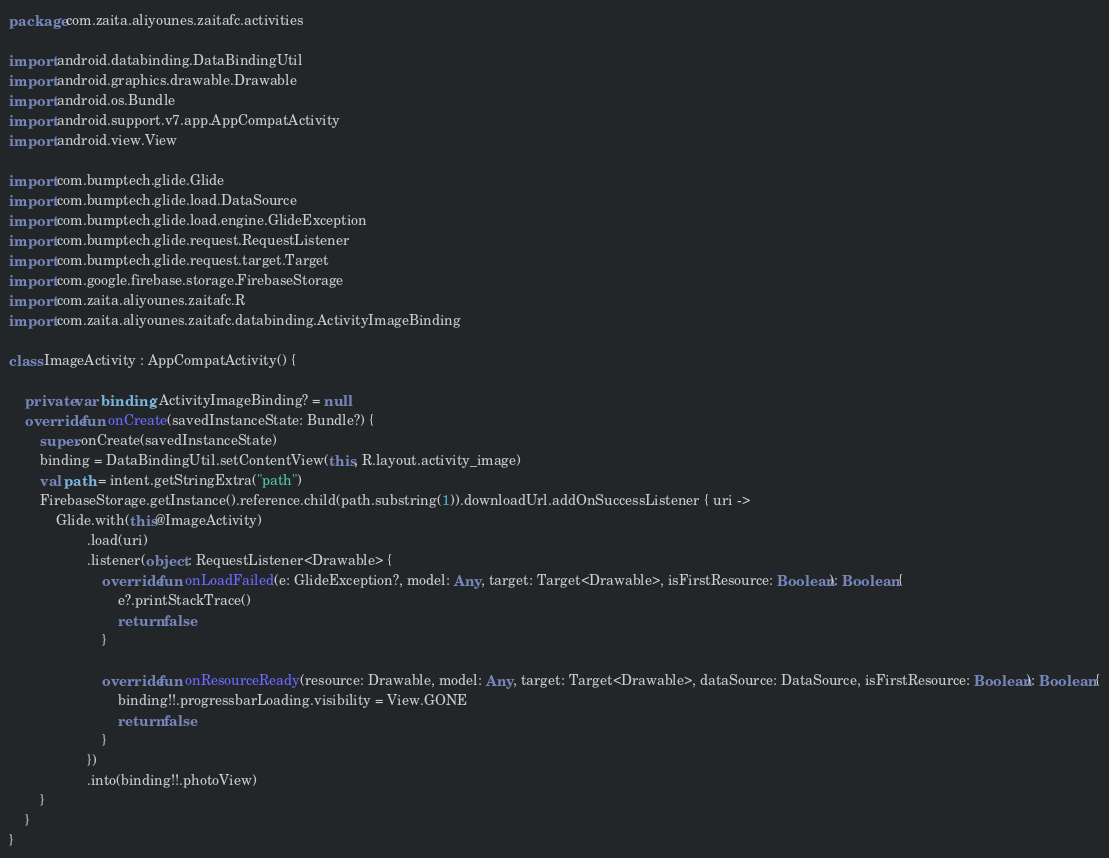<code> <loc_0><loc_0><loc_500><loc_500><_Kotlin_>package com.zaita.aliyounes.zaitafc.activities

import android.databinding.DataBindingUtil
import android.graphics.drawable.Drawable
import android.os.Bundle
import android.support.v7.app.AppCompatActivity
import android.view.View

import com.bumptech.glide.Glide
import com.bumptech.glide.load.DataSource
import com.bumptech.glide.load.engine.GlideException
import com.bumptech.glide.request.RequestListener
import com.bumptech.glide.request.target.Target
import com.google.firebase.storage.FirebaseStorage
import com.zaita.aliyounes.zaitafc.R
import com.zaita.aliyounes.zaitafc.databinding.ActivityImageBinding

class ImageActivity : AppCompatActivity() {

    private var binding: ActivityImageBinding? = null
    override fun onCreate(savedInstanceState: Bundle?) {
        super.onCreate(savedInstanceState)
        binding = DataBindingUtil.setContentView(this, R.layout.activity_image)
        val path = intent.getStringExtra("path")
        FirebaseStorage.getInstance().reference.child(path.substring(1)).downloadUrl.addOnSuccessListener { uri ->
            Glide.with(this@ImageActivity)
                    .load(uri)
                    .listener(object : RequestListener<Drawable> {
                        override fun onLoadFailed(e: GlideException?, model: Any, target: Target<Drawable>, isFirstResource: Boolean): Boolean {
                            e?.printStackTrace()
                            return false
                        }

                        override fun onResourceReady(resource: Drawable, model: Any, target: Target<Drawable>, dataSource: DataSource, isFirstResource: Boolean): Boolean {
                            binding!!.progressbarLoading.visibility = View.GONE
                            return false
                        }
                    })
                    .into(binding!!.photoView)
        }
    }
}
</code> 